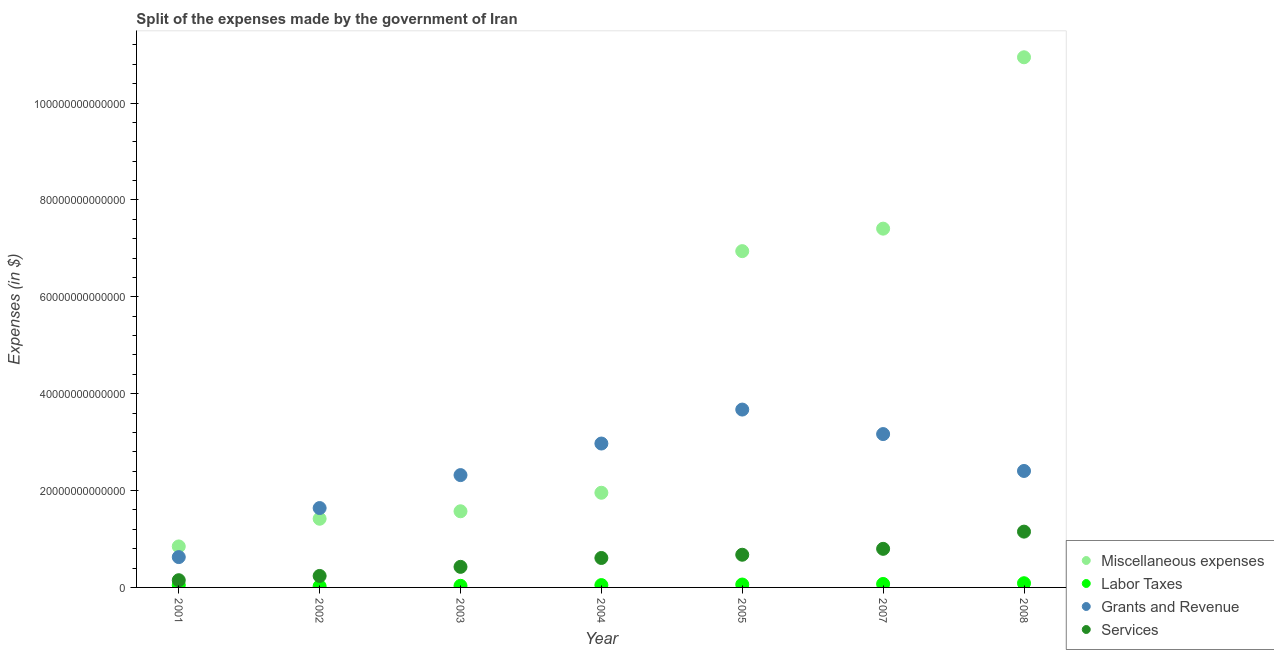How many different coloured dotlines are there?
Ensure brevity in your answer.  4. What is the amount spent on miscellaneous expenses in 2002?
Offer a terse response. 1.42e+13. Across all years, what is the maximum amount spent on services?
Provide a succinct answer. 1.15e+13. Across all years, what is the minimum amount spent on miscellaneous expenses?
Provide a succinct answer. 8.46e+12. In which year was the amount spent on miscellaneous expenses maximum?
Keep it short and to the point. 2008. In which year was the amount spent on services minimum?
Make the answer very short. 2001. What is the total amount spent on services in the graph?
Your answer should be very brief. 4.04e+13. What is the difference between the amount spent on services in 2003 and that in 2008?
Provide a succinct answer. -7.27e+12. What is the difference between the amount spent on miscellaneous expenses in 2007 and the amount spent on labor taxes in 2001?
Provide a succinct answer. 7.36e+13. What is the average amount spent on labor taxes per year?
Your answer should be compact. 5.30e+11. In the year 2005, what is the difference between the amount spent on miscellaneous expenses and amount spent on labor taxes?
Keep it short and to the point. 6.88e+13. What is the ratio of the amount spent on miscellaneous expenses in 2002 to that in 2007?
Your answer should be very brief. 0.19. Is the amount spent on miscellaneous expenses in 2005 less than that in 2007?
Provide a short and direct response. Yes. What is the difference between the highest and the second highest amount spent on grants and revenue?
Keep it short and to the point. 5.06e+12. What is the difference between the highest and the lowest amount spent on grants and revenue?
Your answer should be very brief. 3.05e+13. In how many years, is the amount spent on grants and revenue greater than the average amount spent on grants and revenue taken over all years?
Give a very brief answer. 4. Is the sum of the amount spent on labor taxes in 2001 and 2008 greater than the maximum amount spent on services across all years?
Keep it short and to the point. No. Is it the case that in every year, the sum of the amount spent on services and amount spent on miscellaneous expenses is greater than the sum of amount spent on grants and revenue and amount spent on labor taxes?
Your answer should be very brief. No. Does the amount spent on labor taxes monotonically increase over the years?
Your response must be concise. No. Is the amount spent on services strictly greater than the amount spent on miscellaneous expenses over the years?
Provide a short and direct response. No. How many dotlines are there?
Make the answer very short. 4. What is the difference between two consecutive major ticks on the Y-axis?
Offer a terse response. 2.00e+13. How are the legend labels stacked?
Your answer should be compact. Vertical. What is the title of the graph?
Your answer should be compact. Split of the expenses made by the government of Iran. Does "Primary schools" appear as one of the legend labels in the graph?
Your answer should be compact. No. What is the label or title of the X-axis?
Keep it short and to the point. Year. What is the label or title of the Y-axis?
Ensure brevity in your answer.  Expenses (in $). What is the Expenses (in $) of Miscellaneous expenses in 2001?
Your answer should be very brief. 8.46e+12. What is the Expenses (in $) in Labor Taxes in 2001?
Your response must be concise. 4.72e+11. What is the Expenses (in $) in Grants and Revenue in 2001?
Provide a short and direct response. 6.26e+12. What is the Expenses (in $) in Services in 2001?
Make the answer very short. 1.49e+12. What is the Expenses (in $) in Miscellaneous expenses in 2002?
Offer a very short reply. 1.42e+13. What is the Expenses (in $) in Labor Taxes in 2002?
Your response must be concise. 2.47e+11. What is the Expenses (in $) in Grants and Revenue in 2002?
Make the answer very short. 1.64e+13. What is the Expenses (in $) of Services in 2002?
Your response must be concise. 2.37e+12. What is the Expenses (in $) in Miscellaneous expenses in 2003?
Provide a short and direct response. 1.57e+13. What is the Expenses (in $) in Labor Taxes in 2003?
Offer a very short reply. 3.32e+11. What is the Expenses (in $) of Grants and Revenue in 2003?
Offer a terse response. 2.32e+13. What is the Expenses (in $) in Services in 2003?
Ensure brevity in your answer.  4.25e+12. What is the Expenses (in $) in Miscellaneous expenses in 2004?
Keep it short and to the point. 1.95e+13. What is the Expenses (in $) in Labor Taxes in 2004?
Make the answer very short. 4.82e+11. What is the Expenses (in $) of Grants and Revenue in 2004?
Your answer should be very brief. 2.97e+13. What is the Expenses (in $) in Services in 2004?
Your answer should be very brief. 6.08e+12. What is the Expenses (in $) in Miscellaneous expenses in 2005?
Make the answer very short. 6.94e+13. What is the Expenses (in $) in Labor Taxes in 2005?
Give a very brief answer. 5.99e+11. What is the Expenses (in $) in Grants and Revenue in 2005?
Provide a short and direct response. 3.67e+13. What is the Expenses (in $) of Services in 2005?
Ensure brevity in your answer.  6.75e+12. What is the Expenses (in $) in Miscellaneous expenses in 2007?
Give a very brief answer. 7.41e+13. What is the Expenses (in $) of Labor Taxes in 2007?
Make the answer very short. 7.15e+11. What is the Expenses (in $) in Grants and Revenue in 2007?
Your answer should be compact. 3.17e+13. What is the Expenses (in $) in Services in 2007?
Offer a terse response. 7.97e+12. What is the Expenses (in $) of Miscellaneous expenses in 2008?
Make the answer very short. 1.09e+14. What is the Expenses (in $) of Labor Taxes in 2008?
Provide a succinct answer. 8.66e+11. What is the Expenses (in $) in Grants and Revenue in 2008?
Make the answer very short. 2.40e+13. What is the Expenses (in $) in Services in 2008?
Offer a terse response. 1.15e+13. Across all years, what is the maximum Expenses (in $) of Miscellaneous expenses?
Make the answer very short. 1.09e+14. Across all years, what is the maximum Expenses (in $) in Labor Taxes?
Offer a very short reply. 8.66e+11. Across all years, what is the maximum Expenses (in $) in Grants and Revenue?
Provide a short and direct response. 3.67e+13. Across all years, what is the maximum Expenses (in $) of Services?
Ensure brevity in your answer.  1.15e+13. Across all years, what is the minimum Expenses (in $) in Miscellaneous expenses?
Provide a short and direct response. 8.46e+12. Across all years, what is the minimum Expenses (in $) of Labor Taxes?
Keep it short and to the point. 2.47e+11. Across all years, what is the minimum Expenses (in $) in Grants and Revenue?
Provide a succinct answer. 6.26e+12. Across all years, what is the minimum Expenses (in $) of Services?
Offer a very short reply. 1.49e+12. What is the total Expenses (in $) of Miscellaneous expenses in the graph?
Your response must be concise. 3.11e+14. What is the total Expenses (in $) of Labor Taxes in the graph?
Your answer should be compact. 3.71e+12. What is the total Expenses (in $) of Grants and Revenue in the graph?
Give a very brief answer. 1.68e+14. What is the total Expenses (in $) of Services in the graph?
Your answer should be compact. 4.04e+13. What is the difference between the Expenses (in $) of Miscellaneous expenses in 2001 and that in 2002?
Provide a short and direct response. -5.72e+12. What is the difference between the Expenses (in $) of Labor Taxes in 2001 and that in 2002?
Offer a very short reply. 2.25e+11. What is the difference between the Expenses (in $) in Grants and Revenue in 2001 and that in 2002?
Make the answer very short. -1.01e+13. What is the difference between the Expenses (in $) in Services in 2001 and that in 2002?
Ensure brevity in your answer.  -8.78e+11. What is the difference between the Expenses (in $) of Miscellaneous expenses in 2001 and that in 2003?
Your response must be concise. -7.26e+12. What is the difference between the Expenses (in $) of Labor Taxes in 2001 and that in 2003?
Give a very brief answer. 1.40e+11. What is the difference between the Expenses (in $) in Grants and Revenue in 2001 and that in 2003?
Provide a succinct answer. -1.69e+13. What is the difference between the Expenses (in $) of Services in 2001 and that in 2003?
Your answer should be compact. -2.76e+12. What is the difference between the Expenses (in $) of Miscellaneous expenses in 2001 and that in 2004?
Your answer should be compact. -1.11e+13. What is the difference between the Expenses (in $) of Labor Taxes in 2001 and that in 2004?
Provide a short and direct response. -1.00e+1. What is the difference between the Expenses (in $) of Grants and Revenue in 2001 and that in 2004?
Offer a very short reply. -2.34e+13. What is the difference between the Expenses (in $) in Services in 2001 and that in 2004?
Your answer should be compact. -4.59e+12. What is the difference between the Expenses (in $) in Miscellaneous expenses in 2001 and that in 2005?
Offer a terse response. -6.10e+13. What is the difference between the Expenses (in $) in Labor Taxes in 2001 and that in 2005?
Provide a short and direct response. -1.27e+11. What is the difference between the Expenses (in $) of Grants and Revenue in 2001 and that in 2005?
Your response must be concise. -3.05e+13. What is the difference between the Expenses (in $) of Services in 2001 and that in 2005?
Make the answer very short. -5.26e+12. What is the difference between the Expenses (in $) in Miscellaneous expenses in 2001 and that in 2007?
Provide a short and direct response. -6.56e+13. What is the difference between the Expenses (in $) in Labor Taxes in 2001 and that in 2007?
Make the answer very short. -2.43e+11. What is the difference between the Expenses (in $) of Grants and Revenue in 2001 and that in 2007?
Your response must be concise. -2.54e+13. What is the difference between the Expenses (in $) of Services in 2001 and that in 2007?
Offer a terse response. -6.48e+12. What is the difference between the Expenses (in $) of Miscellaneous expenses in 2001 and that in 2008?
Provide a short and direct response. -1.01e+14. What is the difference between the Expenses (in $) in Labor Taxes in 2001 and that in 2008?
Give a very brief answer. -3.94e+11. What is the difference between the Expenses (in $) in Grants and Revenue in 2001 and that in 2008?
Offer a very short reply. -1.78e+13. What is the difference between the Expenses (in $) in Services in 2001 and that in 2008?
Your response must be concise. -1.00e+13. What is the difference between the Expenses (in $) of Miscellaneous expenses in 2002 and that in 2003?
Your response must be concise. -1.54e+12. What is the difference between the Expenses (in $) in Labor Taxes in 2002 and that in 2003?
Your response must be concise. -8.50e+1. What is the difference between the Expenses (in $) of Grants and Revenue in 2002 and that in 2003?
Your answer should be compact. -6.80e+12. What is the difference between the Expenses (in $) in Services in 2002 and that in 2003?
Your answer should be very brief. -1.88e+12. What is the difference between the Expenses (in $) of Miscellaneous expenses in 2002 and that in 2004?
Offer a terse response. -5.37e+12. What is the difference between the Expenses (in $) in Labor Taxes in 2002 and that in 2004?
Your answer should be very brief. -2.35e+11. What is the difference between the Expenses (in $) in Grants and Revenue in 2002 and that in 2004?
Make the answer very short. -1.33e+13. What is the difference between the Expenses (in $) of Services in 2002 and that in 2004?
Ensure brevity in your answer.  -3.71e+12. What is the difference between the Expenses (in $) of Miscellaneous expenses in 2002 and that in 2005?
Ensure brevity in your answer.  -5.52e+13. What is the difference between the Expenses (in $) of Labor Taxes in 2002 and that in 2005?
Ensure brevity in your answer.  -3.52e+11. What is the difference between the Expenses (in $) in Grants and Revenue in 2002 and that in 2005?
Provide a short and direct response. -2.03e+13. What is the difference between the Expenses (in $) of Services in 2002 and that in 2005?
Offer a terse response. -4.38e+12. What is the difference between the Expenses (in $) in Miscellaneous expenses in 2002 and that in 2007?
Provide a short and direct response. -5.99e+13. What is the difference between the Expenses (in $) of Labor Taxes in 2002 and that in 2007?
Give a very brief answer. -4.68e+11. What is the difference between the Expenses (in $) of Grants and Revenue in 2002 and that in 2007?
Make the answer very short. -1.53e+13. What is the difference between the Expenses (in $) of Services in 2002 and that in 2007?
Keep it short and to the point. -5.60e+12. What is the difference between the Expenses (in $) in Miscellaneous expenses in 2002 and that in 2008?
Offer a very short reply. -9.53e+13. What is the difference between the Expenses (in $) of Labor Taxes in 2002 and that in 2008?
Provide a succinct answer. -6.19e+11. What is the difference between the Expenses (in $) of Grants and Revenue in 2002 and that in 2008?
Provide a succinct answer. -7.66e+12. What is the difference between the Expenses (in $) of Services in 2002 and that in 2008?
Ensure brevity in your answer.  -9.15e+12. What is the difference between the Expenses (in $) in Miscellaneous expenses in 2003 and that in 2004?
Provide a short and direct response. -3.82e+12. What is the difference between the Expenses (in $) in Labor Taxes in 2003 and that in 2004?
Offer a terse response. -1.50e+11. What is the difference between the Expenses (in $) of Grants and Revenue in 2003 and that in 2004?
Keep it short and to the point. -6.52e+12. What is the difference between the Expenses (in $) of Services in 2003 and that in 2004?
Your response must be concise. -1.83e+12. What is the difference between the Expenses (in $) of Miscellaneous expenses in 2003 and that in 2005?
Provide a short and direct response. -5.37e+13. What is the difference between the Expenses (in $) in Labor Taxes in 2003 and that in 2005?
Offer a terse response. -2.67e+11. What is the difference between the Expenses (in $) in Grants and Revenue in 2003 and that in 2005?
Provide a short and direct response. -1.35e+13. What is the difference between the Expenses (in $) in Services in 2003 and that in 2005?
Your answer should be very brief. -2.50e+12. What is the difference between the Expenses (in $) in Miscellaneous expenses in 2003 and that in 2007?
Your answer should be very brief. -5.83e+13. What is the difference between the Expenses (in $) in Labor Taxes in 2003 and that in 2007?
Offer a very short reply. -3.83e+11. What is the difference between the Expenses (in $) of Grants and Revenue in 2003 and that in 2007?
Offer a very short reply. -8.47e+12. What is the difference between the Expenses (in $) in Services in 2003 and that in 2007?
Offer a very short reply. -3.72e+12. What is the difference between the Expenses (in $) in Miscellaneous expenses in 2003 and that in 2008?
Give a very brief answer. -9.37e+13. What is the difference between the Expenses (in $) in Labor Taxes in 2003 and that in 2008?
Provide a succinct answer. -5.34e+11. What is the difference between the Expenses (in $) of Grants and Revenue in 2003 and that in 2008?
Offer a terse response. -8.54e+11. What is the difference between the Expenses (in $) of Services in 2003 and that in 2008?
Provide a succinct answer. -7.27e+12. What is the difference between the Expenses (in $) of Miscellaneous expenses in 2004 and that in 2005?
Give a very brief answer. -4.99e+13. What is the difference between the Expenses (in $) in Labor Taxes in 2004 and that in 2005?
Your response must be concise. -1.17e+11. What is the difference between the Expenses (in $) of Grants and Revenue in 2004 and that in 2005?
Offer a very short reply. -7.01e+12. What is the difference between the Expenses (in $) in Services in 2004 and that in 2005?
Provide a short and direct response. -6.68e+11. What is the difference between the Expenses (in $) in Miscellaneous expenses in 2004 and that in 2007?
Keep it short and to the point. -5.45e+13. What is the difference between the Expenses (in $) in Labor Taxes in 2004 and that in 2007?
Ensure brevity in your answer.  -2.33e+11. What is the difference between the Expenses (in $) of Grants and Revenue in 2004 and that in 2007?
Provide a succinct answer. -1.95e+12. What is the difference between the Expenses (in $) of Services in 2004 and that in 2007?
Your response must be concise. -1.89e+12. What is the difference between the Expenses (in $) in Miscellaneous expenses in 2004 and that in 2008?
Give a very brief answer. -8.99e+13. What is the difference between the Expenses (in $) of Labor Taxes in 2004 and that in 2008?
Give a very brief answer. -3.84e+11. What is the difference between the Expenses (in $) of Grants and Revenue in 2004 and that in 2008?
Offer a terse response. 5.66e+12. What is the difference between the Expenses (in $) in Services in 2004 and that in 2008?
Your response must be concise. -5.44e+12. What is the difference between the Expenses (in $) in Miscellaneous expenses in 2005 and that in 2007?
Ensure brevity in your answer.  -4.64e+12. What is the difference between the Expenses (in $) of Labor Taxes in 2005 and that in 2007?
Provide a succinct answer. -1.16e+11. What is the difference between the Expenses (in $) of Grants and Revenue in 2005 and that in 2007?
Ensure brevity in your answer.  5.06e+12. What is the difference between the Expenses (in $) of Services in 2005 and that in 2007?
Provide a succinct answer. -1.22e+12. What is the difference between the Expenses (in $) of Miscellaneous expenses in 2005 and that in 2008?
Offer a very short reply. -4.00e+13. What is the difference between the Expenses (in $) in Labor Taxes in 2005 and that in 2008?
Provide a succinct answer. -2.67e+11. What is the difference between the Expenses (in $) in Grants and Revenue in 2005 and that in 2008?
Your answer should be compact. 1.27e+13. What is the difference between the Expenses (in $) of Services in 2005 and that in 2008?
Your answer should be compact. -4.77e+12. What is the difference between the Expenses (in $) of Miscellaneous expenses in 2007 and that in 2008?
Your answer should be very brief. -3.54e+13. What is the difference between the Expenses (in $) in Labor Taxes in 2007 and that in 2008?
Your answer should be very brief. -1.51e+11. What is the difference between the Expenses (in $) in Grants and Revenue in 2007 and that in 2008?
Provide a succinct answer. 7.62e+12. What is the difference between the Expenses (in $) in Services in 2007 and that in 2008?
Your answer should be very brief. -3.55e+12. What is the difference between the Expenses (in $) in Miscellaneous expenses in 2001 and the Expenses (in $) in Labor Taxes in 2002?
Your answer should be compact. 8.22e+12. What is the difference between the Expenses (in $) in Miscellaneous expenses in 2001 and the Expenses (in $) in Grants and Revenue in 2002?
Your answer should be very brief. -7.92e+12. What is the difference between the Expenses (in $) of Miscellaneous expenses in 2001 and the Expenses (in $) of Services in 2002?
Provide a short and direct response. 6.09e+12. What is the difference between the Expenses (in $) in Labor Taxes in 2001 and the Expenses (in $) in Grants and Revenue in 2002?
Your answer should be compact. -1.59e+13. What is the difference between the Expenses (in $) of Labor Taxes in 2001 and the Expenses (in $) of Services in 2002?
Provide a succinct answer. -1.90e+12. What is the difference between the Expenses (in $) of Grants and Revenue in 2001 and the Expenses (in $) of Services in 2002?
Offer a very short reply. 3.89e+12. What is the difference between the Expenses (in $) in Miscellaneous expenses in 2001 and the Expenses (in $) in Labor Taxes in 2003?
Your answer should be very brief. 8.13e+12. What is the difference between the Expenses (in $) of Miscellaneous expenses in 2001 and the Expenses (in $) of Grants and Revenue in 2003?
Give a very brief answer. -1.47e+13. What is the difference between the Expenses (in $) in Miscellaneous expenses in 2001 and the Expenses (in $) in Services in 2003?
Your answer should be compact. 4.22e+12. What is the difference between the Expenses (in $) of Labor Taxes in 2001 and the Expenses (in $) of Grants and Revenue in 2003?
Provide a short and direct response. -2.27e+13. What is the difference between the Expenses (in $) in Labor Taxes in 2001 and the Expenses (in $) in Services in 2003?
Give a very brief answer. -3.78e+12. What is the difference between the Expenses (in $) of Grants and Revenue in 2001 and the Expenses (in $) of Services in 2003?
Your answer should be very brief. 2.02e+12. What is the difference between the Expenses (in $) of Miscellaneous expenses in 2001 and the Expenses (in $) of Labor Taxes in 2004?
Your answer should be very brief. 7.98e+12. What is the difference between the Expenses (in $) of Miscellaneous expenses in 2001 and the Expenses (in $) of Grants and Revenue in 2004?
Provide a succinct answer. -2.12e+13. What is the difference between the Expenses (in $) of Miscellaneous expenses in 2001 and the Expenses (in $) of Services in 2004?
Your answer should be compact. 2.38e+12. What is the difference between the Expenses (in $) in Labor Taxes in 2001 and the Expenses (in $) in Grants and Revenue in 2004?
Your answer should be very brief. -2.92e+13. What is the difference between the Expenses (in $) in Labor Taxes in 2001 and the Expenses (in $) in Services in 2004?
Offer a very short reply. -5.61e+12. What is the difference between the Expenses (in $) of Grants and Revenue in 2001 and the Expenses (in $) of Services in 2004?
Your response must be concise. 1.83e+11. What is the difference between the Expenses (in $) of Miscellaneous expenses in 2001 and the Expenses (in $) of Labor Taxes in 2005?
Keep it short and to the point. 7.86e+12. What is the difference between the Expenses (in $) of Miscellaneous expenses in 2001 and the Expenses (in $) of Grants and Revenue in 2005?
Give a very brief answer. -2.83e+13. What is the difference between the Expenses (in $) in Miscellaneous expenses in 2001 and the Expenses (in $) in Services in 2005?
Offer a very short reply. 1.72e+12. What is the difference between the Expenses (in $) in Labor Taxes in 2001 and the Expenses (in $) in Grants and Revenue in 2005?
Make the answer very short. -3.62e+13. What is the difference between the Expenses (in $) in Labor Taxes in 2001 and the Expenses (in $) in Services in 2005?
Your response must be concise. -6.28e+12. What is the difference between the Expenses (in $) of Grants and Revenue in 2001 and the Expenses (in $) of Services in 2005?
Give a very brief answer. -4.85e+11. What is the difference between the Expenses (in $) in Miscellaneous expenses in 2001 and the Expenses (in $) in Labor Taxes in 2007?
Your answer should be compact. 7.75e+12. What is the difference between the Expenses (in $) of Miscellaneous expenses in 2001 and the Expenses (in $) of Grants and Revenue in 2007?
Your response must be concise. -2.32e+13. What is the difference between the Expenses (in $) in Miscellaneous expenses in 2001 and the Expenses (in $) in Services in 2007?
Your answer should be very brief. 4.97e+11. What is the difference between the Expenses (in $) in Labor Taxes in 2001 and the Expenses (in $) in Grants and Revenue in 2007?
Your answer should be very brief. -3.12e+13. What is the difference between the Expenses (in $) in Labor Taxes in 2001 and the Expenses (in $) in Services in 2007?
Your response must be concise. -7.50e+12. What is the difference between the Expenses (in $) of Grants and Revenue in 2001 and the Expenses (in $) of Services in 2007?
Offer a terse response. -1.70e+12. What is the difference between the Expenses (in $) of Miscellaneous expenses in 2001 and the Expenses (in $) of Labor Taxes in 2008?
Your answer should be very brief. 7.60e+12. What is the difference between the Expenses (in $) of Miscellaneous expenses in 2001 and the Expenses (in $) of Grants and Revenue in 2008?
Offer a very short reply. -1.56e+13. What is the difference between the Expenses (in $) in Miscellaneous expenses in 2001 and the Expenses (in $) in Services in 2008?
Offer a terse response. -3.06e+12. What is the difference between the Expenses (in $) in Labor Taxes in 2001 and the Expenses (in $) in Grants and Revenue in 2008?
Keep it short and to the point. -2.36e+13. What is the difference between the Expenses (in $) in Labor Taxes in 2001 and the Expenses (in $) in Services in 2008?
Your response must be concise. -1.10e+13. What is the difference between the Expenses (in $) in Grants and Revenue in 2001 and the Expenses (in $) in Services in 2008?
Make the answer very short. -5.26e+12. What is the difference between the Expenses (in $) of Miscellaneous expenses in 2002 and the Expenses (in $) of Labor Taxes in 2003?
Provide a succinct answer. 1.38e+13. What is the difference between the Expenses (in $) of Miscellaneous expenses in 2002 and the Expenses (in $) of Grants and Revenue in 2003?
Keep it short and to the point. -9.01e+12. What is the difference between the Expenses (in $) of Miscellaneous expenses in 2002 and the Expenses (in $) of Services in 2003?
Give a very brief answer. 9.93e+12. What is the difference between the Expenses (in $) in Labor Taxes in 2002 and the Expenses (in $) in Grants and Revenue in 2003?
Provide a short and direct response. -2.29e+13. What is the difference between the Expenses (in $) in Labor Taxes in 2002 and the Expenses (in $) in Services in 2003?
Provide a succinct answer. -4.00e+12. What is the difference between the Expenses (in $) of Grants and Revenue in 2002 and the Expenses (in $) of Services in 2003?
Give a very brief answer. 1.21e+13. What is the difference between the Expenses (in $) of Miscellaneous expenses in 2002 and the Expenses (in $) of Labor Taxes in 2004?
Your answer should be compact. 1.37e+13. What is the difference between the Expenses (in $) of Miscellaneous expenses in 2002 and the Expenses (in $) of Grants and Revenue in 2004?
Your answer should be very brief. -1.55e+13. What is the difference between the Expenses (in $) in Miscellaneous expenses in 2002 and the Expenses (in $) in Services in 2004?
Offer a terse response. 8.10e+12. What is the difference between the Expenses (in $) of Labor Taxes in 2002 and the Expenses (in $) of Grants and Revenue in 2004?
Make the answer very short. -2.95e+13. What is the difference between the Expenses (in $) of Labor Taxes in 2002 and the Expenses (in $) of Services in 2004?
Give a very brief answer. -5.83e+12. What is the difference between the Expenses (in $) in Grants and Revenue in 2002 and the Expenses (in $) in Services in 2004?
Provide a short and direct response. 1.03e+13. What is the difference between the Expenses (in $) of Miscellaneous expenses in 2002 and the Expenses (in $) of Labor Taxes in 2005?
Your answer should be very brief. 1.36e+13. What is the difference between the Expenses (in $) in Miscellaneous expenses in 2002 and the Expenses (in $) in Grants and Revenue in 2005?
Give a very brief answer. -2.25e+13. What is the difference between the Expenses (in $) in Miscellaneous expenses in 2002 and the Expenses (in $) in Services in 2005?
Your answer should be very brief. 7.43e+12. What is the difference between the Expenses (in $) of Labor Taxes in 2002 and the Expenses (in $) of Grants and Revenue in 2005?
Provide a short and direct response. -3.65e+13. What is the difference between the Expenses (in $) in Labor Taxes in 2002 and the Expenses (in $) in Services in 2005?
Your answer should be compact. -6.50e+12. What is the difference between the Expenses (in $) of Grants and Revenue in 2002 and the Expenses (in $) of Services in 2005?
Your response must be concise. 9.64e+12. What is the difference between the Expenses (in $) of Miscellaneous expenses in 2002 and the Expenses (in $) of Labor Taxes in 2007?
Keep it short and to the point. 1.35e+13. What is the difference between the Expenses (in $) of Miscellaneous expenses in 2002 and the Expenses (in $) of Grants and Revenue in 2007?
Your answer should be compact. -1.75e+13. What is the difference between the Expenses (in $) in Miscellaneous expenses in 2002 and the Expenses (in $) in Services in 2007?
Your answer should be compact. 6.21e+12. What is the difference between the Expenses (in $) of Labor Taxes in 2002 and the Expenses (in $) of Grants and Revenue in 2007?
Ensure brevity in your answer.  -3.14e+13. What is the difference between the Expenses (in $) of Labor Taxes in 2002 and the Expenses (in $) of Services in 2007?
Your response must be concise. -7.72e+12. What is the difference between the Expenses (in $) of Grants and Revenue in 2002 and the Expenses (in $) of Services in 2007?
Your answer should be compact. 8.42e+12. What is the difference between the Expenses (in $) of Miscellaneous expenses in 2002 and the Expenses (in $) of Labor Taxes in 2008?
Your answer should be compact. 1.33e+13. What is the difference between the Expenses (in $) in Miscellaneous expenses in 2002 and the Expenses (in $) in Grants and Revenue in 2008?
Give a very brief answer. -9.87e+12. What is the difference between the Expenses (in $) in Miscellaneous expenses in 2002 and the Expenses (in $) in Services in 2008?
Provide a succinct answer. 2.66e+12. What is the difference between the Expenses (in $) in Labor Taxes in 2002 and the Expenses (in $) in Grants and Revenue in 2008?
Offer a very short reply. -2.38e+13. What is the difference between the Expenses (in $) of Labor Taxes in 2002 and the Expenses (in $) of Services in 2008?
Your response must be concise. -1.13e+13. What is the difference between the Expenses (in $) in Grants and Revenue in 2002 and the Expenses (in $) in Services in 2008?
Keep it short and to the point. 4.87e+12. What is the difference between the Expenses (in $) in Miscellaneous expenses in 2003 and the Expenses (in $) in Labor Taxes in 2004?
Your answer should be very brief. 1.52e+13. What is the difference between the Expenses (in $) of Miscellaneous expenses in 2003 and the Expenses (in $) of Grants and Revenue in 2004?
Your response must be concise. -1.40e+13. What is the difference between the Expenses (in $) in Miscellaneous expenses in 2003 and the Expenses (in $) in Services in 2004?
Make the answer very short. 9.64e+12. What is the difference between the Expenses (in $) in Labor Taxes in 2003 and the Expenses (in $) in Grants and Revenue in 2004?
Ensure brevity in your answer.  -2.94e+13. What is the difference between the Expenses (in $) of Labor Taxes in 2003 and the Expenses (in $) of Services in 2004?
Provide a succinct answer. -5.75e+12. What is the difference between the Expenses (in $) in Grants and Revenue in 2003 and the Expenses (in $) in Services in 2004?
Provide a succinct answer. 1.71e+13. What is the difference between the Expenses (in $) in Miscellaneous expenses in 2003 and the Expenses (in $) in Labor Taxes in 2005?
Provide a short and direct response. 1.51e+13. What is the difference between the Expenses (in $) of Miscellaneous expenses in 2003 and the Expenses (in $) of Grants and Revenue in 2005?
Your answer should be very brief. -2.10e+13. What is the difference between the Expenses (in $) in Miscellaneous expenses in 2003 and the Expenses (in $) in Services in 2005?
Make the answer very short. 8.97e+12. What is the difference between the Expenses (in $) in Labor Taxes in 2003 and the Expenses (in $) in Grants and Revenue in 2005?
Your answer should be compact. -3.64e+13. What is the difference between the Expenses (in $) of Labor Taxes in 2003 and the Expenses (in $) of Services in 2005?
Provide a short and direct response. -6.42e+12. What is the difference between the Expenses (in $) of Grants and Revenue in 2003 and the Expenses (in $) of Services in 2005?
Make the answer very short. 1.64e+13. What is the difference between the Expenses (in $) in Miscellaneous expenses in 2003 and the Expenses (in $) in Labor Taxes in 2007?
Your answer should be compact. 1.50e+13. What is the difference between the Expenses (in $) in Miscellaneous expenses in 2003 and the Expenses (in $) in Grants and Revenue in 2007?
Provide a short and direct response. -1.59e+13. What is the difference between the Expenses (in $) of Miscellaneous expenses in 2003 and the Expenses (in $) of Services in 2007?
Your answer should be compact. 7.76e+12. What is the difference between the Expenses (in $) of Labor Taxes in 2003 and the Expenses (in $) of Grants and Revenue in 2007?
Ensure brevity in your answer.  -3.13e+13. What is the difference between the Expenses (in $) of Labor Taxes in 2003 and the Expenses (in $) of Services in 2007?
Your answer should be very brief. -7.64e+12. What is the difference between the Expenses (in $) of Grants and Revenue in 2003 and the Expenses (in $) of Services in 2007?
Offer a terse response. 1.52e+13. What is the difference between the Expenses (in $) of Miscellaneous expenses in 2003 and the Expenses (in $) of Labor Taxes in 2008?
Provide a short and direct response. 1.49e+13. What is the difference between the Expenses (in $) of Miscellaneous expenses in 2003 and the Expenses (in $) of Grants and Revenue in 2008?
Your answer should be compact. -8.32e+12. What is the difference between the Expenses (in $) in Miscellaneous expenses in 2003 and the Expenses (in $) in Services in 2008?
Your response must be concise. 4.20e+12. What is the difference between the Expenses (in $) in Labor Taxes in 2003 and the Expenses (in $) in Grants and Revenue in 2008?
Ensure brevity in your answer.  -2.37e+13. What is the difference between the Expenses (in $) in Labor Taxes in 2003 and the Expenses (in $) in Services in 2008?
Offer a very short reply. -1.12e+13. What is the difference between the Expenses (in $) of Grants and Revenue in 2003 and the Expenses (in $) of Services in 2008?
Provide a succinct answer. 1.17e+13. What is the difference between the Expenses (in $) of Miscellaneous expenses in 2004 and the Expenses (in $) of Labor Taxes in 2005?
Your response must be concise. 1.89e+13. What is the difference between the Expenses (in $) of Miscellaneous expenses in 2004 and the Expenses (in $) of Grants and Revenue in 2005?
Your answer should be very brief. -1.72e+13. What is the difference between the Expenses (in $) of Miscellaneous expenses in 2004 and the Expenses (in $) of Services in 2005?
Your answer should be compact. 1.28e+13. What is the difference between the Expenses (in $) of Labor Taxes in 2004 and the Expenses (in $) of Grants and Revenue in 2005?
Provide a succinct answer. -3.62e+13. What is the difference between the Expenses (in $) of Labor Taxes in 2004 and the Expenses (in $) of Services in 2005?
Offer a terse response. -6.27e+12. What is the difference between the Expenses (in $) in Grants and Revenue in 2004 and the Expenses (in $) in Services in 2005?
Provide a short and direct response. 2.30e+13. What is the difference between the Expenses (in $) of Miscellaneous expenses in 2004 and the Expenses (in $) of Labor Taxes in 2007?
Provide a short and direct response. 1.88e+13. What is the difference between the Expenses (in $) of Miscellaneous expenses in 2004 and the Expenses (in $) of Grants and Revenue in 2007?
Your response must be concise. -1.21e+13. What is the difference between the Expenses (in $) in Miscellaneous expenses in 2004 and the Expenses (in $) in Services in 2007?
Give a very brief answer. 1.16e+13. What is the difference between the Expenses (in $) in Labor Taxes in 2004 and the Expenses (in $) in Grants and Revenue in 2007?
Ensure brevity in your answer.  -3.12e+13. What is the difference between the Expenses (in $) of Labor Taxes in 2004 and the Expenses (in $) of Services in 2007?
Provide a short and direct response. -7.48e+12. What is the difference between the Expenses (in $) of Grants and Revenue in 2004 and the Expenses (in $) of Services in 2007?
Offer a terse response. 2.17e+13. What is the difference between the Expenses (in $) in Miscellaneous expenses in 2004 and the Expenses (in $) in Labor Taxes in 2008?
Give a very brief answer. 1.87e+13. What is the difference between the Expenses (in $) in Miscellaneous expenses in 2004 and the Expenses (in $) in Grants and Revenue in 2008?
Your answer should be very brief. -4.50e+12. What is the difference between the Expenses (in $) of Miscellaneous expenses in 2004 and the Expenses (in $) of Services in 2008?
Provide a succinct answer. 8.03e+12. What is the difference between the Expenses (in $) in Labor Taxes in 2004 and the Expenses (in $) in Grants and Revenue in 2008?
Offer a terse response. -2.36e+13. What is the difference between the Expenses (in $) in Labor Taxes in 2004 and the Expenses (in $) in Services in 2008?
Your answer should be very brief. -1.10e+13. What is the difference between the Expenses (in $) of Grants and Revenue in 2004 and the Expenses (in $) of Services in 2008?
Your response must be concise. 1.82e+13. What is the difference between the Expenses (in $) of Miscellaneous expenses in 2005 and the Expenses (in $) of Labor Taxes in 2007?
Make the answer very short. 6.87e+13. What is the difference between the Expenses (in $) of Miscellaneous expenses in 2005 and the Expenses (in $) of Grants and Revenue in 2007?
Offer a very short reply. 3.78e+13. What is the difference between the Expenses (in $) of Miscellaneous expenses in 2005 and the Expenses (in $) of Services in 2007?
Offer a very short reply. 6.15e+13. What is the difference between the Expenses (in $) of Labor Taxes in 2005 and the Expenses (in $) of Grants and Revenue in 2007?
Your answer should be very brief. -3.11e+13. What is the difference between the Expenses (in $) in Labor Taxes in 2005 and the Expenses (in $) in Services in 2007?
Your answer should be compact. -7.37e+12. What is the difference between the Expenses (in $) of Grants and Revenue in 2005 and the Expenses (in $) of Services in 2007?
Keep it short and to the point. 2.88e+13. What is the difference between the Expenses (in $) of Miscellaneous expenses in 2005 and the Expenses (in $) of Labor Taxes in 2008?
Give a very brief answer. 6.86e+13. What is the difference between the Expenses (in $) in Miscellaneous expenses in 2005 and the Expenses (in $) in Grants and Revenue in 2008?
Your answer should be compact. 4.54e+13. What is the difference between the Expenses (in $) in Miscellaneous expenses in 2005 and the Expenses (in $) in Services in 2008?
Give a very brief answer. 5.79e+13. What is the difference between the Expenses (in $) in Labor Taxes in 2005 and the Expenses (in $) in Grants and Revenue in 2008?
Offer a terse response. -2.34e+13. What is the difference between the Expenses (in $) in Labor Taxes in 2005 and the Expenses (in $) in Services in 2008?
Your answer should be very brief. -1.09e+13. What is the difference between the Expenses (in $) of Grants and Revenue in 2005 and the Expenses (in $) of Services in 2008?
Your response must be concise. 2.52e+13. What is the difference between the Expenses (in $) in Miscellaneous expenses in 2007 and the Expenses (in $) in Labor Taxes in 2008?
Keep it short and to the point. 7.32e+13. What is the difference between the Expenses (in $) in Miscellaneous expenses in 2007 and the Expenses (in $) in Grants and Revenue in 2008?
Make the answer very short. 5.00e+13. What is the difference between the Expenses (in $) of Miscellaneous expenses in 2007 and the Expenses (in $) of Services in 2008?
Give a very brief answer. 6.26e+13. What is the difference between the Expenses (in $) of Labor Taxes in 2007 and the Expenses (in $) of Grants and Revenue in 2008?
Your response must be concise. -2.33e+13. What is the difference between the Expenses (in $) of Labor Taxes in 2007 and the Expenses (in $) of Services in 2008?
Your answer should be very brief. -1.08e+13. What is the difference between the Expenses (in $) in Grants and Revenue in 2007 and the Expenses (in $) in Services in 2008?
Offer a very short reply. 2.01e+13. What is the average Expenses (in $) in Miscellaneous expenses per year?
Your answer should be compact. 4.44e+13. What is the average Expenses (in $) of Labor Taxes per year?
Give a very brief answer. 5.30e+11. What is the average Expenses (in $) of Grants and Revenue per year?
Provide a succinct answer. 2.40e+13. What is the average Expenses (in $) in Services per year?
Provide a short and direct response. 5.77e+12. In the year 2001, what is the difference between the Expenses (in $) of Miscellaneous expenses and Expenses (in $) of Labor Taxes?
Ensure brevity in your answer.  7.99e+12. In the year 2001, what is the difference between the Expenses (in $) in Miscellaneous expenses and Expenses (in $) in Grants and Revenue?
Give a very brief answer. 2.20e+12. In the year 2001, what is the difference between the Expenses (in $) of Miscellaneous expenses and Expenses (in $) of Services?
Offer a very short reply. 6.97e+12. In the year 2001, what is the difference between the Expenses (in $) in Labor Taxes and Expenses (in $) in Grants and Revenue?
Make the answer very short. -5.79e+12. In the year 2001, what is the difference between the Expenses (in $) of Labor Taxes and Expenses (in $) of Services?
Make the answer very short. -1.02e+12. In the year 2001, what is the difference between the Expenses (in $) in Grants and Revenue and Expenses (in $) in Services?
Offer a terse response. 4.77e+12. In the year 2002, what is the difference between the Expenses (in $) in Miscellaneous expenses and Expenses (in $) in Labor Taxes?
Offer a terse response. 1.39e+13. In the year 2002, what is the difference between the Expenses (in $) in Miscellaneous expenses and Expenses (in $) in Grants and Revenue?
Your answer should be compact. -2.21e+12. In the year 2002, what is the difference between the Expenses (in $) in Miscellaneous expenses and Expenses (in $) in Services?
Your response must be concise. 1.18e+13. In the year 2002, what is the difference between the Expenses (in $) of Labor Taxes and Expenses (in $) of Grants and Revenue?
Offer a very short reply. -1.61e+13. In the year 2002, what is the difference between the Expenses (in $) in Labor Taxes and Expenses (in $) in Services?
Give a very brief answer. -2.12e+12. In the year 2002, what is the difference between the Expenses (in $) of Grants and Revenue and Expenses (in $) of Services?
Your answer should be very brief. 1.40e+13. In the year 2003, what is the difference between the Expenses (in $) of Miscellaneous expenses and Expenses (in $) of Labor Taxes?
Your answer should be compact. 1.54e+13. In the year 2003, what is the difference between the Expenses (in $) in Miscellaneous expenses and Expenses (in $) in Grants and Revenue?
Offer a terse response. -7.47e+12. In the year 2003, what is the difference between the Expenses (in $) of Miscellaneous expenses and Expenses (in $) of Services?
Your response must be concise. 1.15e+13. In the year 2003, what is the difference between the Expenses (in $) in Labor Taxes and Expenses (in $) in Grants and Revenue?
Provide a short and direct response. -2.29e+13. In the year 2003, what is the difference between the Expenses (in $) of Labor Taxes and Expenses (in $) of Services?
Offer a terse response. -3.92e+12. In the year 2003, what is the difference between the Expenses (in $) of Grants and Revenue and Expenses (in $) of Services?
Your answer should be compact. 1.89e+13. In the year 2004, what is the difference between the Expenses (in $) of Miscellaneous expenses and Expenses (in $) of Labor Taxes?
Keep it short and to the point. 1.91e+13. In the year 2004, what is the difference between the Expenses (in $) in Miscellaneous expenses and Expenses (in $) in Grants and Revenue?
Provide a short and direct response. -1.02e+13. In the year 2004, what is the difference between the Expenses (in $) in Miscellaneous expenses and Expenses (in $) in Services?
Provide a short and direct response. 1.35e+13. In the year 2004, what is the difference between the Expenses (in $) of Labor Taxes and Expenses (in $) of Grants and Revenue?
Offer a terse response. -2.92e+13. In the year 2004, what is the difference between the Expenses (in $) in Labor Taxes and Expenses (in $) in Services?
Provide a short and direct response. -5.60e+12. In the year 2004, what is the difference between the Expenses (in $) of Grants and Revenue and Expenses (in $) of Services?
Offer a very short reply. 2.36e+13. In the year 2005, what is the difference between the Expenses (in $) in Miscellaneous expenses and Expenses (in $) in Labor Taxes?
Provide a short and direct response. 6.88e+13. In the year 2005, what is the difference between the Expenses (in $) of Miscellaneous expenses and Expenses (in $) of Grants and Revenue?
Give a very brief answer. 3.27e+13. In the year 2005, what is the difference between the Expenses (in $) of Miscellaneous expenses and Expenses (in $) of Services?
Offer a very short reply. 6.27e+13. In the year 2005, what is the difference between the Expenses (in $) of Labor Taxes and Expenses (in $) of Grants and Revenue?
Provide a short and direct response. -3.61e+13. In the year 2005, what is the difference between the Expenses (in $) in Labor Taxes and Expenses (in $) in Services?
Give a very brief answer. -6.15e+12. In the year 2005, what is the difference between the Expenses (in $) of Grants and Revenue and Expenses (in $) of Services?
Your answer should be very brief. 3.00e+13. In the year 2007, what is the difference between the Expenses (in $) in Miscellaneous expenses and Expenses (in $) in Labor Taxes?
Make the answer very short. 7.34e+13. In the year 2007, what is the difference between the Expenses (in $) of Miscellaneous expenses and Expenses (in $) of Grants and Revenue?
Your response must be concise. 4.24e+13. In the year 2007, what is the difference between the Expenses (in $) in Miscellaneous expenses and Expenses (in $) in Services?
Keep it short and to the point. 6.61e+13. In the year 2007, what is the difference between the Expenses (in $) of Labor Taxes and Expenses (in $) of Grants and Revenue?
Make the answer very short. -3.09e+13. In the year 2007, what is the difference between the Expenses (in $) in Labor Taxes and Expenses (in $) in Services?
Make the answer very short. -7.25e+12. In the year 2007, what is the difference between the Expenses (in $) in Grants and Revenue and Expenses (in $) in Services?
Provide a short and direct response. 2.37e+13. In the year 2008, what is the difference between the Expenses (in $) in Miscellaneous expenses and Expenses (in $) in Labor Taxes?
Provide a succinct answer. 1.09e+14. In the year 2008, what is the difference between the Expenses (in $) of Miscellaneous expenses and Expenses (in $) of Grants and Revenue?
Your answer should be compact. 8.54e+13. In the year 2008, what is the difference between the Expenses (in $) of Miscellaneous expenses and Expenses (in $) of Services?
Your answer should be compact. 9.79e+13. In the year 2008, what is the difference between the Expenses (in $) of Labor Taxes and Expenses (in $) of Grants and Revenue?
Ensure brevity in your answer.  -2.32e+13. In the year 2008, what is the difference between the Expenses (in $) in Labor Taxes and Expenses (in $) in Services?
Offer a terse response. -1.07e+13. In the year 2008, what is the difference between the Expenses (in $) of Grants and Revenue and Expenses (in $) of Services?
Provide a short and direct response. 1.25e+13. What is the ratio of the Expenses (in $) in Miscellaneous expenses in 2001 to that in 2002?
Provide a succinct answer. 0.6. What is the ratio of the Expenses (in $) in Labor Taxes in 2001 to that in 2002?
Offer a very short reply. 1.91. What is the ratio of the Expenses (in $) of Grants and Revenue in 2001 to that in 2002?
Keep it short and to the point. 0.38. What is the ratio of the Expenses (in $) in Services in 2001 to that in 2002?
Your answer should be compact. 0.63. What is the ratio of the Expenses (in $) of Miscellaneous expenses in 2001 to that in 2003?
Ensure brevity in your answer.  0.54. What is the ratio of the Expenses (in $) in Labor Taxes in 2001 to that in 2003?
Offer a very short reply. 1.42. What is the ratio of the Expenses (in $) in Grants and Revenue in 2001 to that in 2003?
Your answer should be very brief. 0.27. What is the ratio of the Expenses (in $) of Services in 2001 to that in 2003?
Your answer should be compact. 0.35. What is the ratio of the Expenses (in $) in Miscellaneous expenses in 2001 to that in 2004?
Give a very brief answer. 0.43. What is the ratio of the Expenses (in $) of Labor Taxes in 2001 to that in 2004?
Your answer should be compact. 0.98. What is the ratio of the Expenses (in $) of Grants and Revenue in 2001 to that in 2004?
Offer a very short reply. 0.21. What is the ratio of the Expenses (in $) in Services in 2001 to that in 2004?
Give a very brief answer. 0.25. What is the ratio of the Expenses (in $) in Miscellaneous expenses in 2001 to that in 2005?
Your response must be concise. 0.12. What is the ratio of the Expenses (in $) of Labor Taxes in 2001 to that in 2005?
Offer a terse response. 0.79. What is the ratio of the Expenses (in $) in Grants and Revenue in 2001 to that in 2005?
Your response must be concise. 0.17. What is the ratio of the Expenses (in $) in Services in 2001 to that in 2005?
Ensure brevity in your answer.  0.22. What is the ratio of the Expenses (in $) of Miscellaneous expenses in 2001 to that in 2007?
Provide a short and direct response. 0.11. What is the ratio of the Expenses (in $) of Labor Taxes in 2001 to that in 2007?
Offer a very short reply. 0.66. What is the ratio of the Expenses (in $) in Grants and Revenue in 2001 to that in 2007?
Your answer should be compact. 0.2. What is the ratio of the Expenses (in $) of Services in 2001 to that in 2007?
Ensure brevity in your answer.  0.19. What is the ratio of the Expenses (in $) of Miscellaneous expenses in 2001 to that in 2008?
Offer a terse response. 0.08. What is the ratio of the Expenses (in $) in Labor Taxes in 2001 to that in 2008?
Make the answer very short. 0.55. What is the ratio of the Expenses (in $) of Grants and Revenue in 2001 to that in 2008?
Make the answer very short. 0.26. What is the ratio of the Expenses (in $) in Services in 2001 to that in 2008?
Offer a very short reply. 0.13. What is the ratio of the Expenses (in $) of Miscellaneous expenses in 2002 to that in 2003?
Offer a very short reply. 0.9. What is the ratio of the Expenses (in $) in Labor Taxes in 2002 to that in 2003?
Provide a succinct answer. 0.74. What is the ratio of the Expenses (in $) of Grants and Revenue in 2002 to that in 2003?
Give a very brief answer. 0.71. What is the ratio of the Expenses (in $) in Services in 2002 to that in 2003?
Your answer should be compact. 0.56. What is the ratio of the Expenses (in $) in Miscellaneous expenses in 2002 to that in 2004?
Keep it short and to the point. 0.73. What is the ratio of the Expenses (in $) of Labor Taxes in 2002 to that in 2004?
Provide a short and direct response. 0.51. What is the ratio of the Expenses (in $) of Grants and Revenue in 2002 to that in 2004?
Offer a very short reply. 0.55. What is the ratio of the Expenses (in $) of Services in 2002 to that in 2004?
Make the answer very short. 0.39. What is the ratio of the Expenses (in $) in Miscellaneous expenses in 2002 to that in 2005?
Provide a short and direct response. 0.2. What is the ratio of the Expenses (in $) of Labor Taxes in 2002 to that in 2005?
Give a very brief answer. 0.41. What is the ratio of the Expenses (in $) in Grants and Revenue in 2002 to that in 2005?
Your answer should be very brief. 0.45. What is the ratio of the Expenses (in $) in Services in 2002 to that in 2005?
Provide a succinct answer. 0.35. What is the ratio of the Expenses (in $) of Miscellaneous expenses in 2002 to that in 2007?
Your response must be concise. 0.19. What is the ratio of the Expenses (in $) in Labor Taxes in 2002 to that in 2007?
Give a very brief answer. 0.35. What is the ratio of the Expenses (in $) in Grants and Revenue in 2002 to that in 2007?
Keep it short and to the point. 0.52. What is the ratio of the Expenses (in $) of Services in 2002 to that in 2007?
Offer a terse response. 0.3. What is the ratio of the Expenses (in $) in Miscellaneous expenses in 2002 to that in 2008?
Your response must be concise. 0.13. What is the ratio of the Expenses (in $) in Labor Taxes in 2002 to that in 2008?
Offer a terse response. 0.29. What is the ratio of the Expenses (in $) of Grants and Revenue in 2002 to that in 2008?
Your answer should be compact. 0.68. What is the ratio of the Expenses (in $) in Services in 2002 to that in 2008?
Ensure brevity in your answer.  0.21. What is the ratio of the Expenses (in $) in Miscellaneous expenses in 2003 to that in 2004?
Your answer should be compact. 0.8. What is the ratio of the Expenses (in $) of Labor Taxes in 2003 to that in 2004?
Your answer should be compact. 0.69. What is the ratio of the Expenses (in $) in Grants and Revenue in 2003 to that in 2004?
Provide a succinct answer. 0.78. What is the ratio of the Expenses (in $) of Services in 2003 to that in 2004?
Provide a succinct answer. 0.7. What is the ratio of the Expenses (in $) in Miscellaneous expenses in 2003 to that in 2005?
Your answer should be very brief. 0.23. What is the ratio of the Expenses (in $) in Labor Taxes in 2003 to that in 2005?
Your answer should be very brief. 0.55. What is the ratio of the Expenses (in $) of Grants and Revenue in 2003 to that in 2005?
Provide a succinct answer. 0.63. What is the ratio of the Expenses (in $) in Services in 2003 to that in 2005?
Ensure brevity in your answer.  0.63. What is the ratio of the Expenses (in $) in Miscellaneous expenses in 2003 to that in 2007?
Offer a terse response. 0.21. What is the ratio of the Expenses (in $) of Labor Taxes in 2003 to that in 2007?
Keep it short and to the point. 0.46. What is the ratio of the Expenses (in $) in Grants and Revenue in 2003 to that in 2007?
Offer a terse response. 0.73. What is the ratio of the Expenses (in $) of Services in 2003 to that in 2007?
Provide a short and direct response. 0.53. What is the ratio of the Expenses (in $) of Miscellaneous expenses in 2003 to that in 2008?
Provide a succinct answer. 0.14. What is the ratio of the Expenses (in $) of Labor Taxes in 2003 to that in 2008?
Keep it short and to the point. 0.38. What is the ratio of the Expenses (in $) in Grants and Revenue in 2003 to that in 2008?
Offer a very short reply. 0.96. What is the ratio of the Expenses (in $) in Services in 2003 to that in 2008?
Your answer should be very brief. 0.37. What is the ratio of the Expenses (in $) in Miscellaneous expenses in 2004 to that in 2005?
Make the answer very short. 0.28. What is the ratio of the Expenses (in $) of Labor Taxes in 2004 to that in 2005?
Provide a short and direct response. 0.8. What is the ratio of the Expenses (in $) in Grants and Revenue in 2004 to that in 2005?
Make the answer very short. 0.81. What is the ratio of the Expenses (in $) in Services in 2004 to that in 2005?
Keep it short and to the point. 0.9. What is the ratio of the Expenses (in $) in Miscellaneous expenses in 2004 to that in 2007?
Provide a short and direct response. 0.26. What is the ratio of the Expenses (in $) of Labor Taxes in 2004 to that in 2007?
Ensure brevity in your answer.  0.67. What is the ratio of the Expenses (in $) in Grants and Revenue in 2004 to that in 2007?
Offer a very short reply. 0.94. What is the ratio of the Expenses (in $) of Services in 2004 to that in 2007?
Your answer should be very brief. 0.76. What is the ratio of the Expenses (in $) of Miscellaneous expenses in 2004 to that in 2008?
Offer a very short reply. 0.18. What is the ratio of the Expenses (in $) of Labor Taxes in 2004 to that in 2008?
Ensure brevity in your answer.  0.56. What is the ratio of the Expenses (in $) of Grants and Revenue in 2004 to that in 2008?
Ensure brevity in your answer.  1.24. What is the ratio of the Expenses (in $) in Services in 2004 to that in 2008?
Your answer should be compact. 0.53. What is the ratio of the Expenses (in $) of Miscellaneous expenses in 2005 to that in 2007?
Offer a terse response. 0.94. What is the ratio of the Expenses (in $) in Labor Taxes in 2005 to that in 2007?
Provide a short and direct response. 0.84. What is the ratio of the Expenses (in $) in Grants and Revenue in 2005 to that in 2007?
Keep it short and to the point. 1.16. What is the ratio of the Expenses (in $) in Services in 2005 to that in 2007?
Your answer should be compact. 0.85. What is the ratio of the Expenses (in $) of Miscellaneous expenses in 2005 to that in 2008?
Provide a short and direct response. 0.63. What is the ratio of the Expenses (in $) in Labor Taxes in 2005 to that in 2008?
Provide a short and direct response. 0.69. What is the ratio of the Expenses (in $) in Grants and Revenue in 2005 to that in 2008?
Offer a very short reply. 1.53. What is the ratio of the Expenses (in $) of Services in 2005 to that in 2008?
Offer a very short reply. 0.59. What is the ratio of the Expenses (in $) of Miscellaneous expenses in 2007 to that in 2008?
Keep it short and to the point. 0.68. What is the ratio of the Expenses (in $) of Labor Taxes in 2007 to that in 2008?
Your answer should be compact. 0.83. What is the ratio of the Expenses (in $) of Grants and Revenue in 2007 to that in 2008?
Offer a very short reply. 1.32. What is the ratio of the Expenses (in $) in Services in 2007 to that in 2008?
Your answer should be very brief. 0.69. What is the difference between the highest and the second highest Expenses (in $) of Miscellaneous expenses?
Provide a succinct answer. 3.54e+13. What is the difference between the highest and the second highest Expenses (in $) of Labor Taxes?
Keep it short and to the point. 1.51e+11. What is the difference between the highest and the second highest Expenses (in $) of Grants and Revenue?
Provide a short and direct response. 5.06e+12. What is the difference between the highest and the second highest Expenses (in $) of Services?
Your response must be concise. 3.55e+12. What is the difference between the highest and the lowest Expenses (in $) of Miscellaneous expenses?
Provide a short and direct response. 1.01e+14. What is the difference between the highest and the lowest Expenses (in $) of Labor Taxes?
Keep it short and to the point. 6.19e+11. What is the difference between the highest and the lowest Expenses (in $) of Grants and Revenue?
Your answer should be very brief. 3.05e+13. What is the difference between the highest and the lowest Expenses (in $) of Services?
Keep it short and to the point. 1.00e+13. 